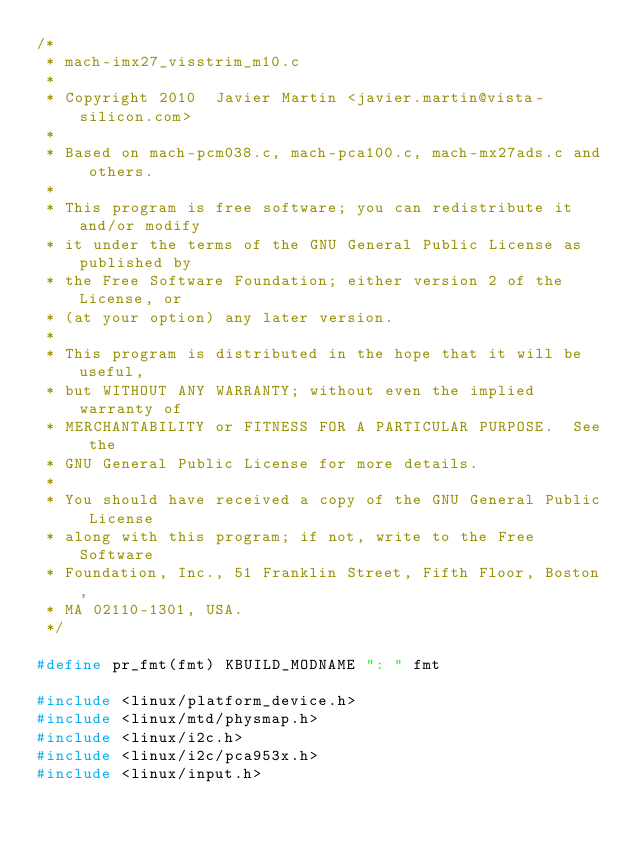Convert code to text. <code><loc_0><loc_0><loc_500><loc_500><_C_>/*
 * mach-imx27_visstrim_m10.c
 *
 * Copyright 2010  Javier Martin <javier.martin@vista-silicon.com>
 *
 * Based on mach-pcm038.c, mach-pca100.c, mach-mx27ads.c and others.
 *
 * This program is free software; you can redistribute it and/or modify
 * it under the terms of the GNU General Public License as published by
 * the Free Software Foundation; either version 2 of the License, or
 * (at your option) any later version.
 *
 * This program is distributed in the hope that it will be useful,
 * but WITHOUT ANY WARRANTY; without even the implied warranty of
 * MERCHANTABILITY or FITNESS FOR A PARTICULAR PURPOSE.  See the
 * GNU General Public License for more details.
 *
 * You should have received a copy of the GNU General Public License
 * along with this program; if not, write to the Free Software
 * Foundation, Inc., 51 Franklin Street, Fifth Floor, Boston,
 * MA 02110-1301, USA.
 */

#define pr_fmt(fmt) KBUILD_MODNAME ": " fmt

#include <linux/platform_device.h>
#include <linux/mtd/physmap.h>
#include <linux/i2c.h>
#include <linux/i2c/pca953x.h>
#include <linux/input.h></code> 